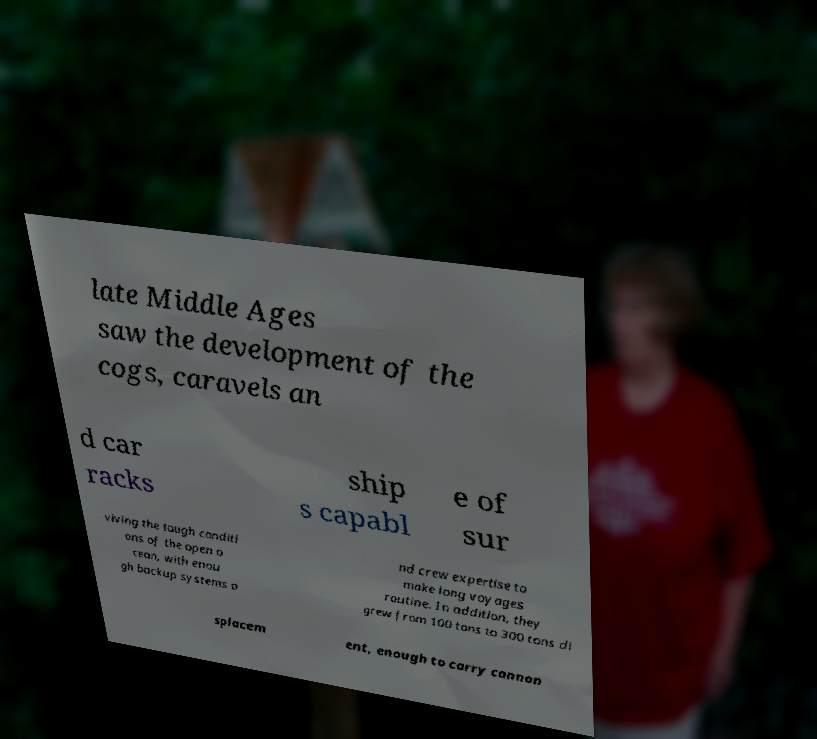Can you read and provide the text displayed in the image?This photo seems to have some interesting text. Can you extract and type it out for me? late Middle Ages saw the development of the cogs, caravels an d car racks ship s capabl e of sur viving the tough conditi ons of the open o cean, with enou gh backup systems a nd crew expertise to make long voyages routine. In addition, they grew from 100 tons to 300 tons di splacem ent, enough to carry cannon 